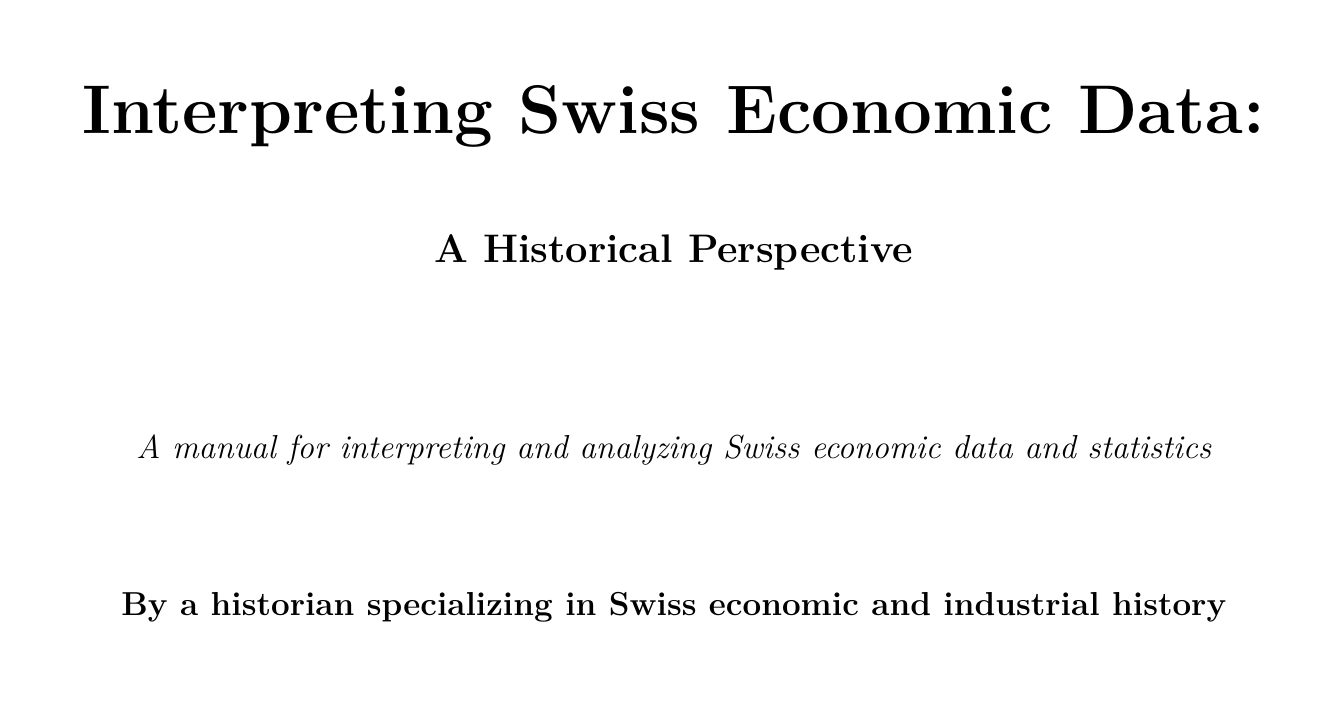What are the two main Swiss statistical agencies mentioned? The document lists the Federal Statistical Office and the Swiss National Bank as the main agencies.
Answer: Federal Statistical Office, Swiss National Bank What period does the manual cover for the evolution of data collection methods in Switzerland? The evolution of data collection methods spans from 1850 to the present.
Answer: 1850-present What is one method discussed for estimating GDP in pre-federal Switzerland? The manual specifically addresses methods for estimating GDP during the 19th century.
Answer: Estimating GDP What event is analyzed in relation to customs data during the Great Depression? The analysis focuses on the impact of the Great Depression using customs data.
Answer: Great Depression What is the time span covered for tracking growth in the banking sector after World War II? The discussion regarding the banking sector's growth occurs between 1945 and 1970.
Answer: 1945-1970 What digital tool is suggested for visualizing historical economic data? The manual mentions using GIS techniques for data visualization.
Answer: GIS techniques Which case study analyzes the Swiss pharmaceutical industry? The specific case study focuses on the rise of the Swiss pharmaceutical industry between 1900 and 1950.
Answer: Swiss pharmaceutical industry (1900-1950) What is one ethical consideration mentioned regarding historical economic data? The manual discusses addressing biases in historical economic data collection as an ethical consideration.
Answer: Addressing biases What type of resource is the Statistisches Jahrbuch der Schweiz? It is described as an annual statistical yearbook published since 1891.
Answer: Annual statistical yearbook 